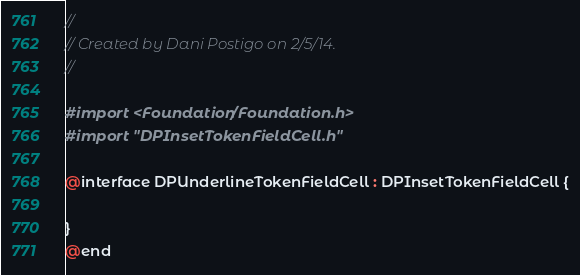Convert code to text. <code><loc_0><loc_0><loc_500><loc_500><_C_>//
// Created by Dani Postigo on 2/5/14.
//

#import <Foundation/Foundation.h>
#import "DPInsetTokenFieldCell.h"

@interface DPUnderlineTokenFieldCell : DPInsetTokenFieldCell {

}
@end</code> 